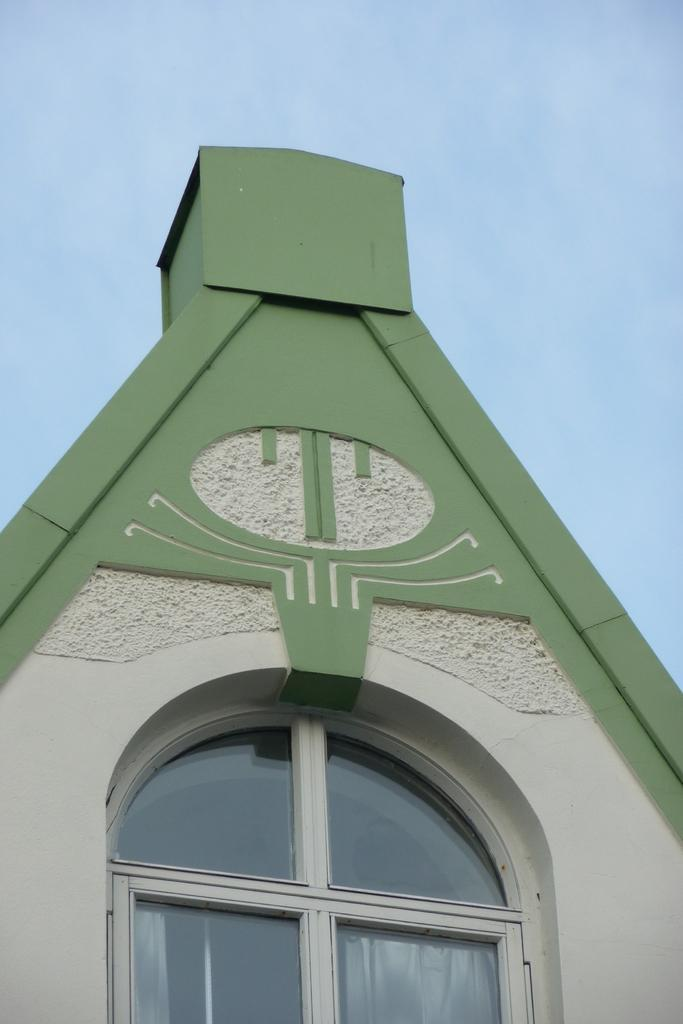What type of structure can be seen in the image? There is a wall in the image. What is present on the wall? There is a glass window in the image. What can be seen in the background of the image? The sky is visible in the background of the image. What type of copper decoration can be seen hanging from the window in the image? There is no copper decoration present in the image. Are there any icicles hanging from the window in the image? There are no icicles visible in the image. 